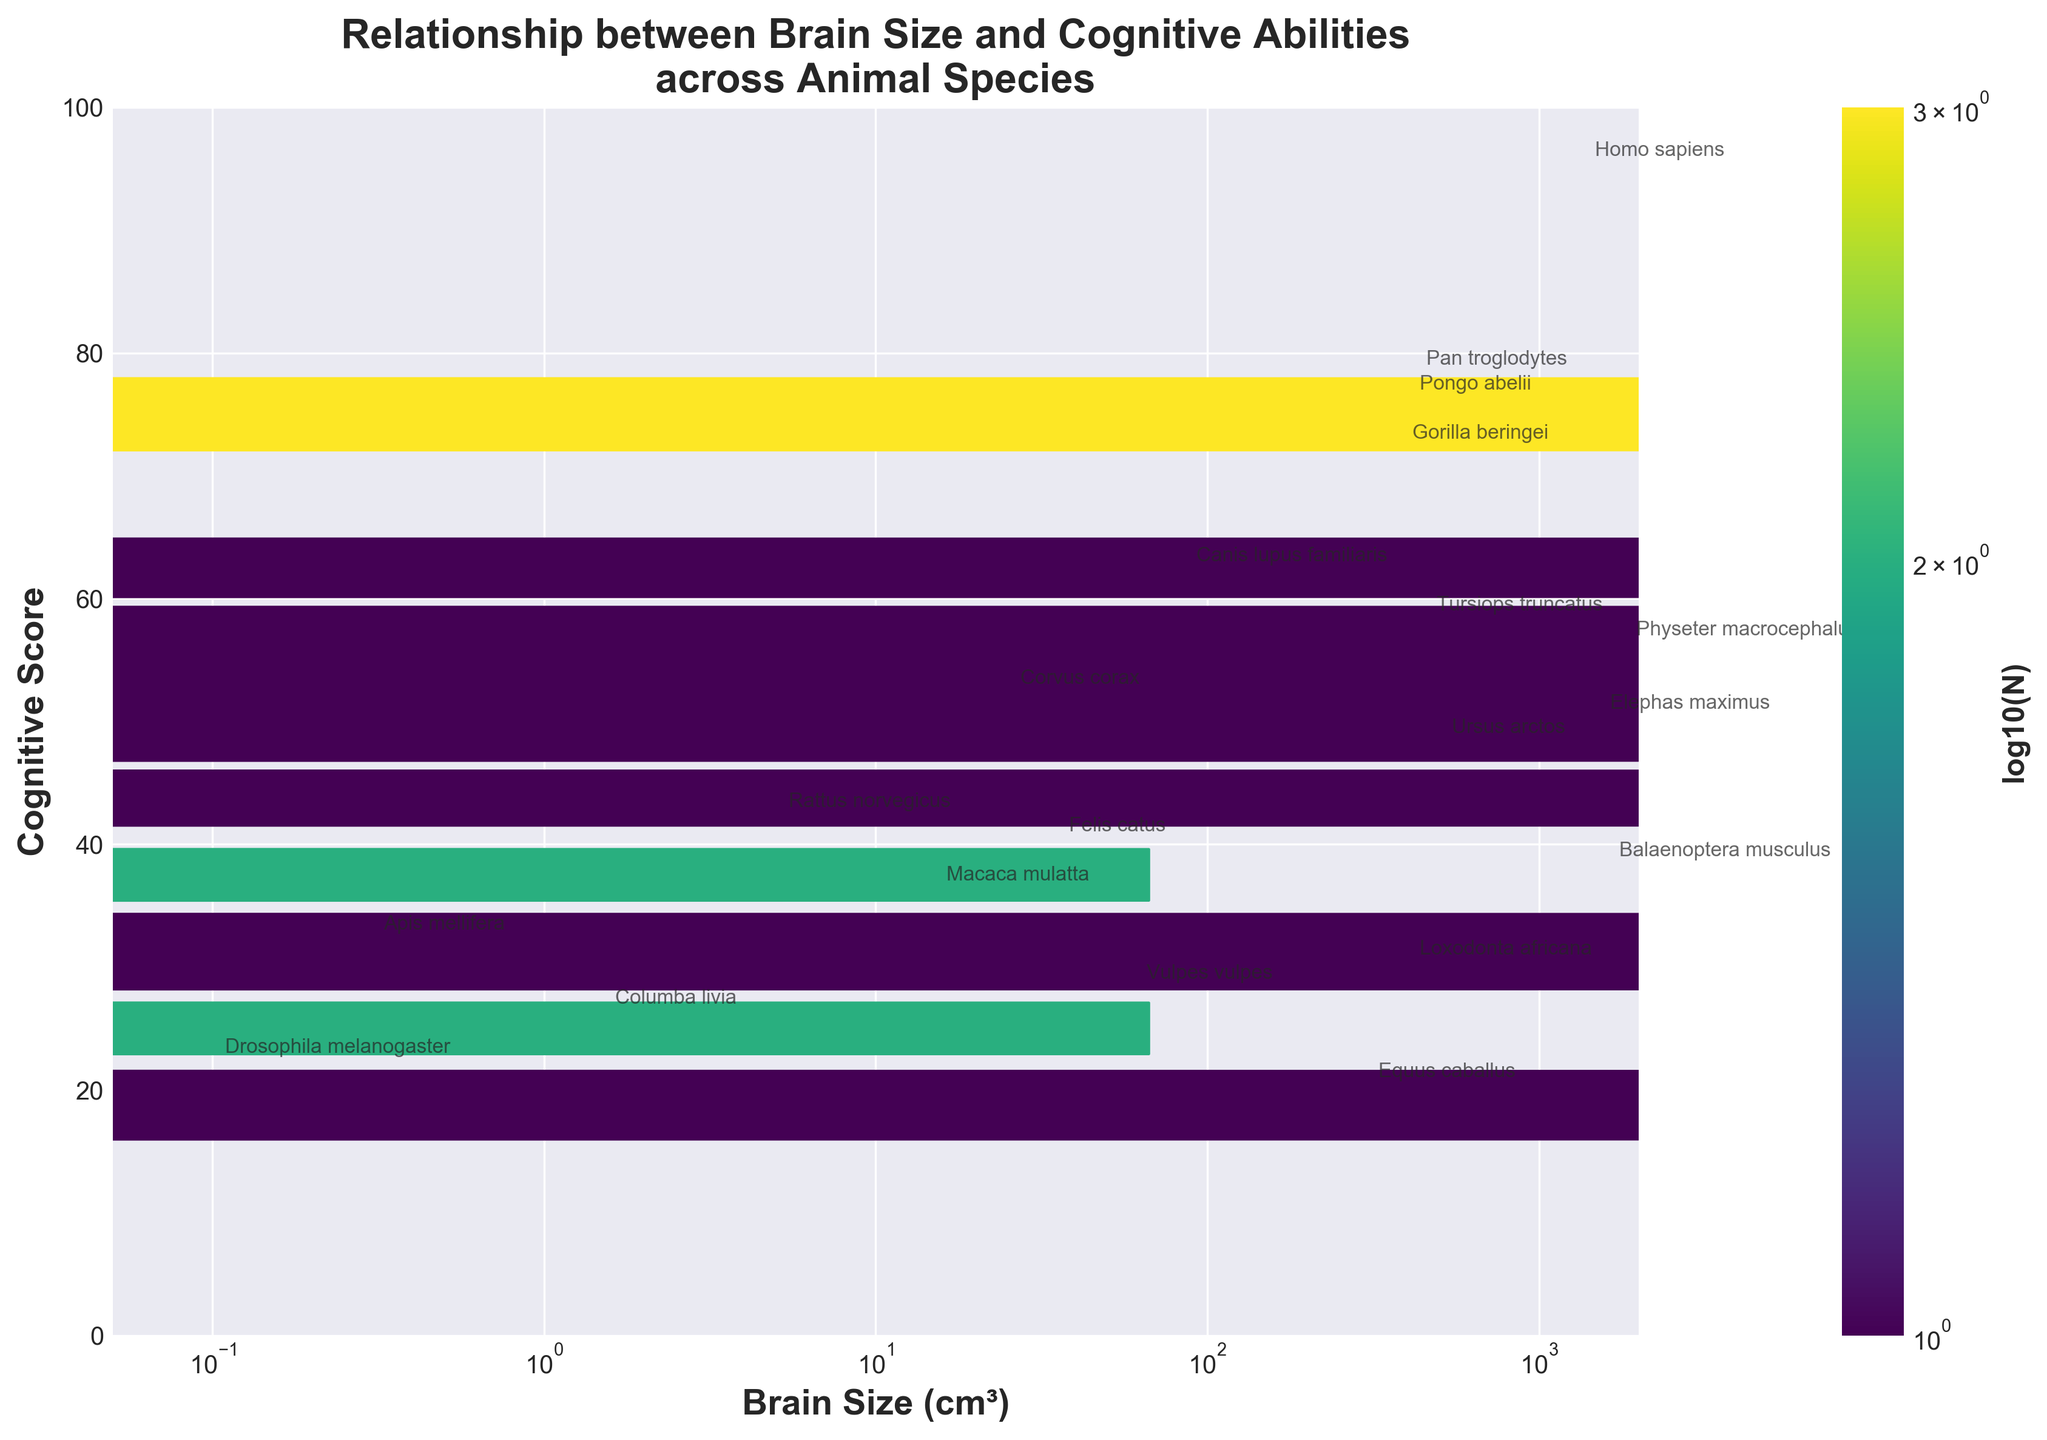What is the title of the hexbin plot? The title is usually displayed at the top of the plot in a larger font.
Answer: Relationship between Brain Size and Cognitive Abilities across Animal Species What are the labels of the x-axis and y-axis? The labels are mentioned next to the x-axis and y-axis to describe the data being plotted.
Answer: Brain Size (cm³) and Cognitive Score How many species have a brain size larger than 1000 cm³? Identify all data points with a brain size larger than 1000 cm³ and count them. From the annotations, the species are Homo sapiens, Physeter macrocephalus, Elephas maximus, and Balaenoptera musculus.
Answer: 4 Which species is shown to have the highest cognitive score? Look for the data point with the maximum y-value (Cognitive Score) and check the annotation.
Answer: Homo sapiens Based on the hexbin plot, do larger brain sizes generally correlate with higher cognitive scores? Observe the distribution of points and the color intensity. Higher cognitive scores appear concentrated with species having larger brain sizes, suggesting a positive correlation.
Answer: Yes What is the color of the hexagons in the plot, and what does it signify? The color of the hexagons is derived from the colormap (viridis), indicating the density of data points in this plot. As the legend shows, darker colors correspond to higher densities.
Answer: Represents data point density Which has a lower cognitive score, Tursiops truncatus (Dolphin) or Gorilla beringei (Gorilla)? Check the Cognitive Score for both species based on annotations. Tursiops truncatus has 58, and Gorilla beringei has 72.
Answer: Tursiops truncatus What is the range of the x-axis and y-axis? The x-axis ranges from 0.05 to 2000 cm³ on a logarithmic scale, and the y-axis ranges from 0 to 100.
Answer: x-axis: 0.05 to 2000 cm³, y-axis: 0 to 100 Compare the cognitive scores of Corvus corax (Common Raven) and Canis lupus familiaris (Dog). Which one is higher? Find the annotated points for these species and compare their y-values. Corvus corax has a cognitive score of 52, while Canis lupus familiaris has 62.
Answer: Canis lupus familiaris 